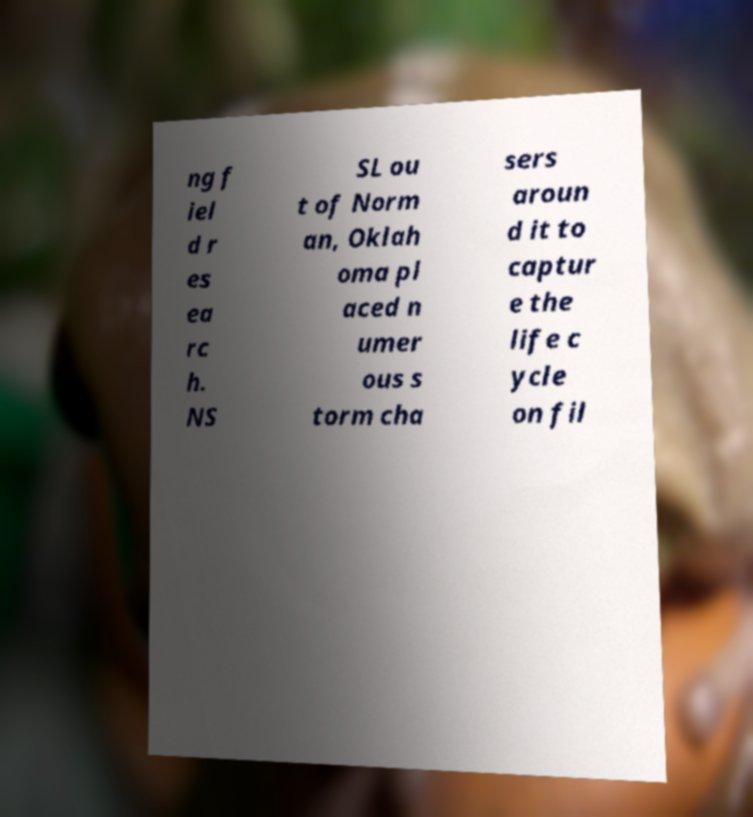Can you accurately transcribe the text from the provided image for me? ng f iel d r es ea rc h. NS SL ou t of Norm an, Oklah oma pl aced n umer ous s torm cha sers aroun d it to captur e the life c ycle on fil 